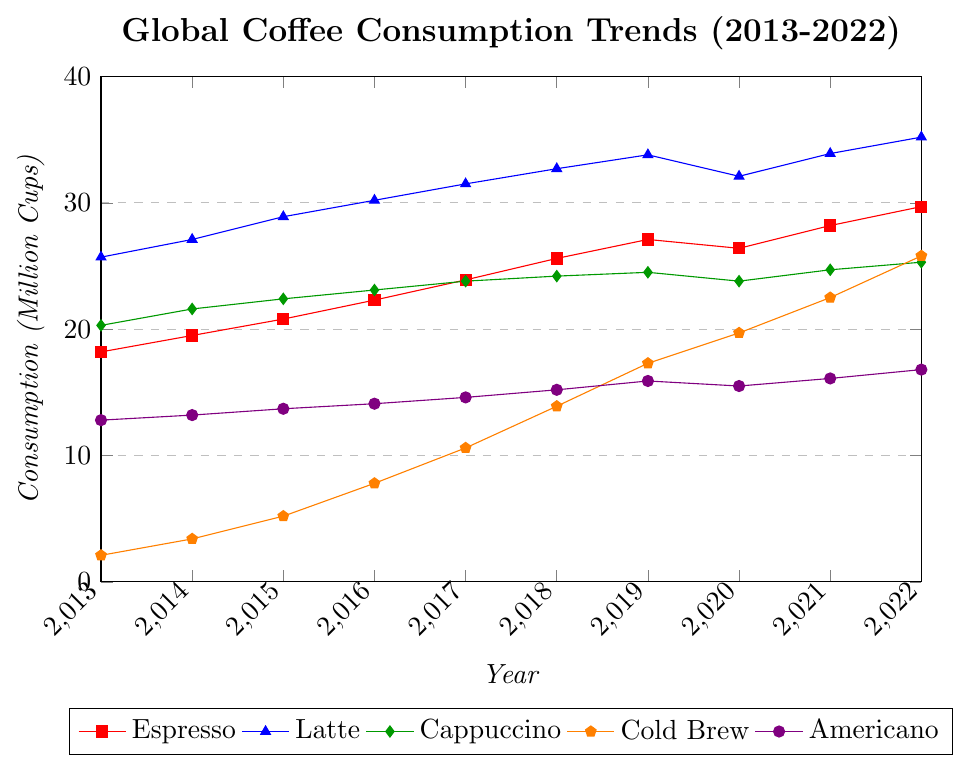Which type of coffee had the highest consumption in 2022? We look at the last data point for each coffee type in 2022. Espresso (29.7), Latte (35.2), Cappuccino (25.3), Cold Brew (25.8), and Americano (16.8). Latte has the highest value at 35.2 million cups.
Answer: Latte How did Cold Brew's consumption change between 2013 and 2022? We compare Cold Brew's consumption in 2013 (2.1 million cups) to 2022 (25.8 million cups). The change is 25.8 - 2.1 = 23.7 million cups increase.
Answer: Increased by 23.7 million cups Between which years did Cappuccino's consumption increase the most? By examining the data each year, the largest increase for Cappuccino happens between 2014 and 2015, where it rose from 21.6 to 22.4 million cups, an increase of 0.8 million cups.
Answer: Between 2014 and 2015 What is the average consumption of Espresso over the decade? Summing the values for Espresso from 2013 to 2022: (18.2 + 19.5 + 20.8 + 22.3 + 23.9 + 25.6 + 27.1 + 26.4 + 28.2 + 29.7) = 241.7. Dividing by 10 years gives 241.7 / 10 = 24.17 million cups.
Answer: 24.17 million cups Which coffee type had the most consistent consumption trend over the decade? Observing the general trend lines, Americano shows the most consistent increase year over year without significant fluctuation compared to the others.
Answer: Americano In what year did Latte consumption see its smallest increase? We find the smallest increase by examining yearly changes for Latte: 2013-2014 (1.4), 2014-2015 (1.8), 2015-2016 (1.3), 2016-2017 (1.3), 2017-2018 (1.2), 2018-2019 (1.1), 2019-2020 (-1.7), 2020-2021 (1.8), 2021-2022 (1.3). The smallest increase is from 2018 to 2019 with 1.1 million cups.
Answer: 2018 to 2019 By how much did Americano consumption increase from 2017 to 2022? We compare Americano consumption in 2017 (14.6 million cups) to 2022 (16.8 million cups). The increase is 16.8 - 14.6 = 2.2 million cups.
Answer: Increased by 2.2 million cups Which type of coffee experienced a dip in consumption at some point and then recovered by 2022? Espresso saw a dip from 2019 (27.1) to 2020 (26.4), then recovered in subsequent years to reach 29.7 million cups by 2022.
Answer: Espresso 